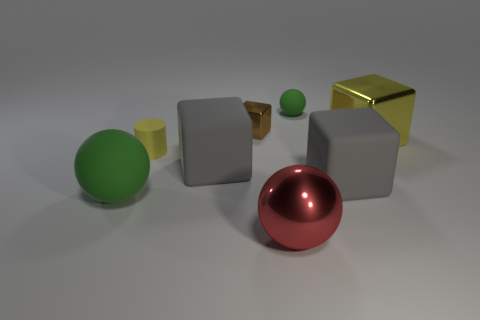Add 2 tiny gray balls. How many objects exist? 10 Subtract all shiny spheres. How many spheres are left? 2 Subtract all red balls. How many balls are left? 2 Subtract 1 cylinders. How many cylinders are left? 0 Subtract all brown cubes. Subtract all yellow cylinders. How many cubes are left? 3 Subtract all gray cylinders. How many red spheres are left? 1 Subtract all tiny brown matte blocks. Subtract all large matte cubes. How many objects are left? 6 Add 8 yellow metallic objects. How many yellow metallic objects are left? 9 Add 5 metallic blocks. How many metallic blocks exist? 7 Subtract 0 brown spheres. How many objects are left? 8 